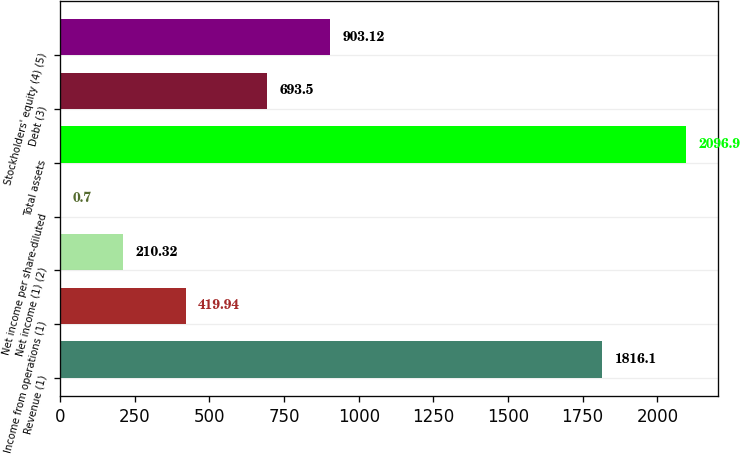Convert chart to OTSL. <chart><loc_0><loc_0><loc_500><loc_500><bar_chart><fcel>Revenue (1)<fcel>Income from operations (1)<fcel>Net income (1) (2)<fcel>Net income per share-diluted<fcel>Total assets<fcel>Debt (3)<fcel>Stockholders' equity (4) (5)<nl><fcel>1816.1<fcel>419.94<fcel>210.32<fcel>0.7<fcel>2096.9<fcel>693.5<fcel>903.12<nl></chart> 